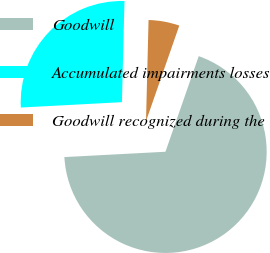Convert chart to OTSL. <chart><loc_0><loc_0><loc_500><loc_500><pie_chart><fcel>Goodwill<fcel>Accumulated impairments losses<fcel>Goodwill recognized during the<nl><fcel>68.83%<fcel>26.24%<fcel>4.93%<nl></chart> 